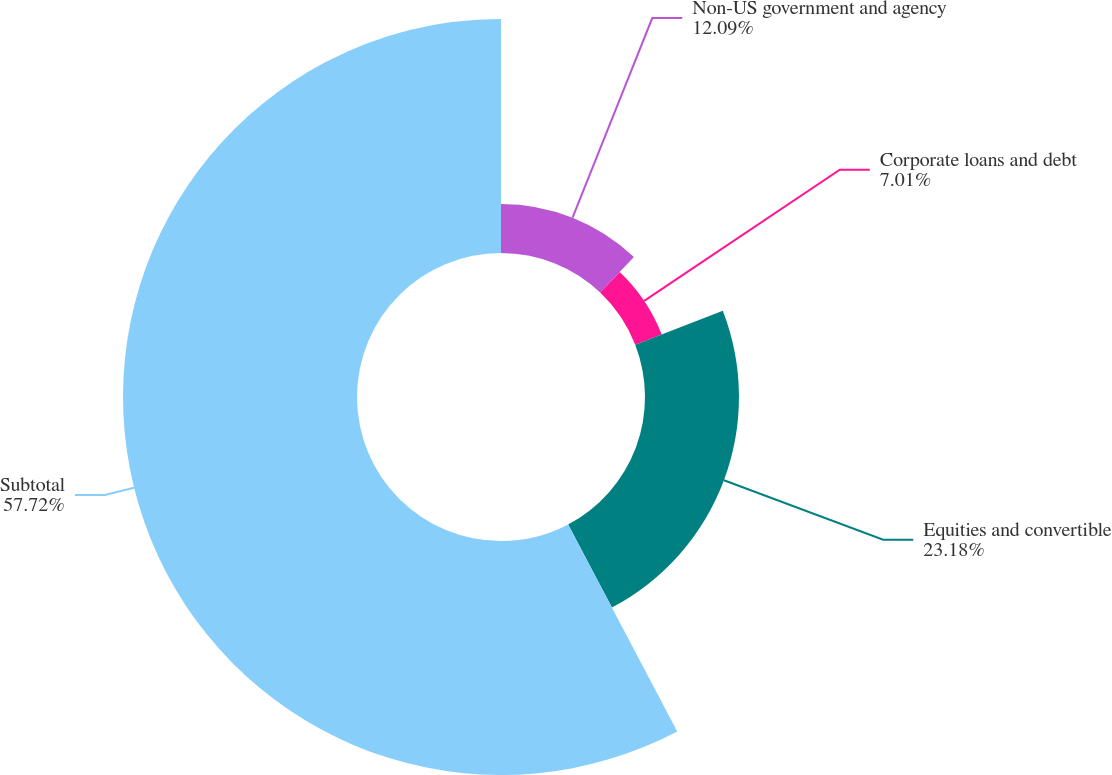Convert chart. <chart><loc_0><loc_0><loc_500><loc_500><pie_chart><fcel>Non-US government and agency<fcel>Corporate loans and debt<fcel>Equities and convertible<fcel>Subtotal<nl><fcel>12.09%<fcel>7.01%<fcel>23.18%<fcel>57.72%<nl></chart> 